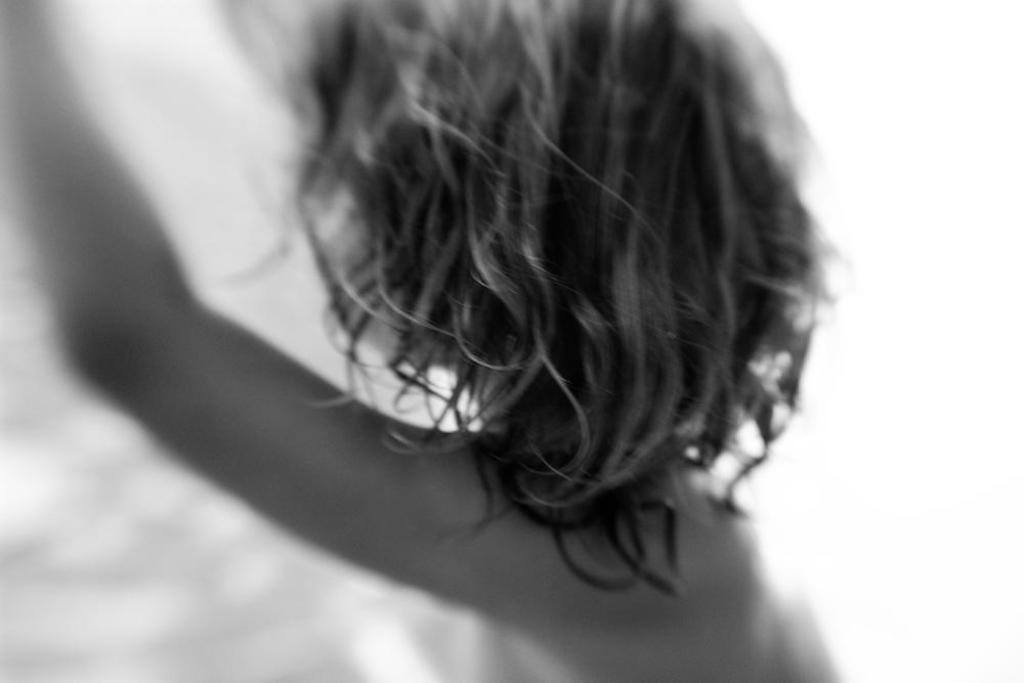How would you summarize this image in a sentence or two? The picture is blurred, in this picture there is a person. 